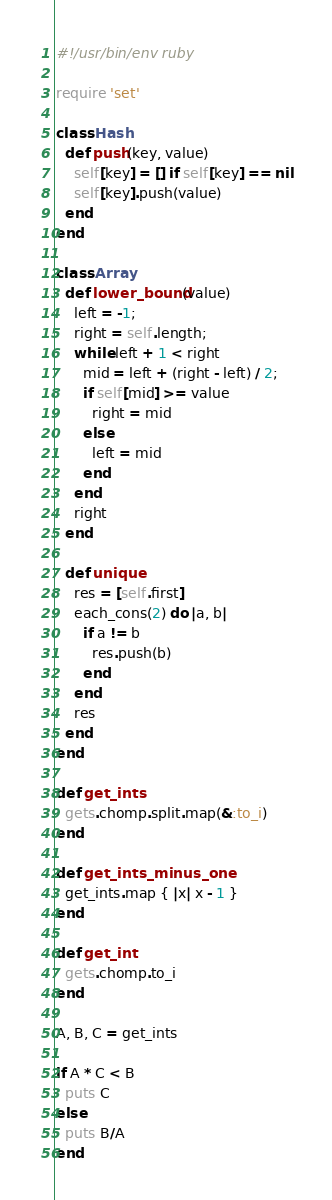Convert code to text. <code><loc_0><loc_0><loc_500><loc_500><_Ruby_>#!/usr/bin/env ruby

require 'set'

class Hash
  def push(key, value)
    self[key] = [] if self[key] == nil
    self[key].push(value)
  end
end

class Array
  def lower_bound(value)
    left = -1;
    right = self.length;
    while left + 1 < right
      mid = left + (right - left) / 2;
      if self[mid] >= value
        right = mid
      else
        left = mid
      end
    end
    right
  end

  def unique
    res = [self.first]
    each_cons(2) do |a, b|
      if a != b
        res.push(b)
      end
    end
    res
  end
end

def get_ints
  gets.chomp.split.map(&:to_i)
end

def get_ints_minus_one
  get_ints.map { |x| x - 1 }
end

def get_int
  gets.chomp.to_i
end

A, B, C = get_ints

if A * C < B
  puts C
else
  puts B/A
end
</code> 